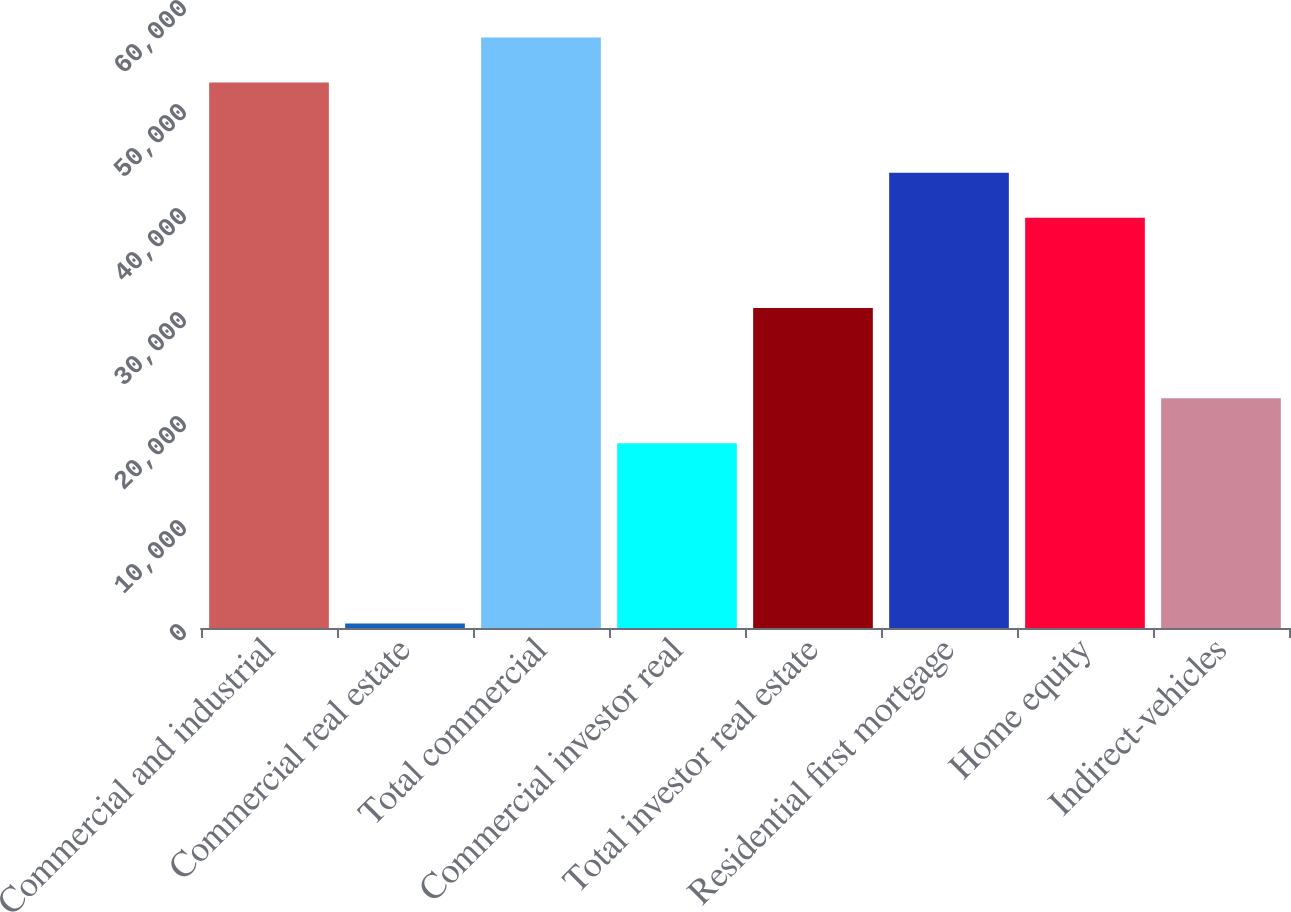Convert chart to OTSL. <chart><loc_0><loc_0><loc_500><loc_500><bar_chart><fcel>Commercial and industrial<fcel>Commercial real estate<fcel>Total commercial<fcel>Commercial investor real<fcel>Total investor real estate<fcel>Residential first mortgage<fcel>Home equity<fcel>Indirect-vehicles<nl><fcel>52453.8<fcel>423<fcel>56789.7<fcel>17766.6<fcel>30774.3<fcel>43782<fcel>39446.1<fcel>22102.5<nl></chart> 